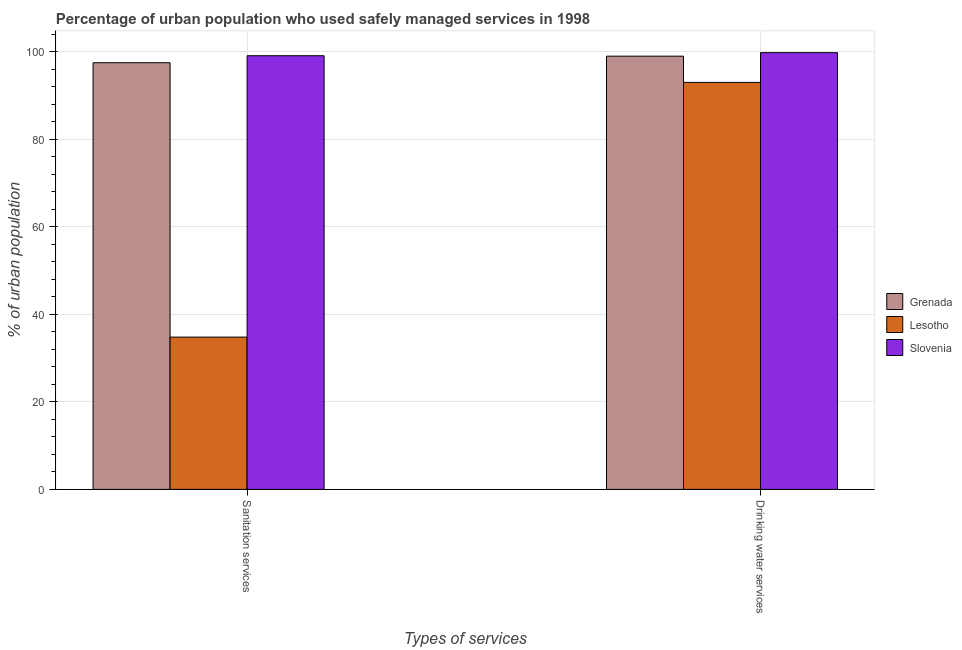How many different coloured bars are there?
Keep it short and to the point. 3. How many groups of bars are there?
Offer a very short reply. 2. What is the label of the 1st group of bars from the left?
Provide a succinct answer. Sanitation services. What is the percentage of urban population who used sanitation services in Lesotho?
Keep it short and to the point. 34.8. Across all countries, what is the maximum percentage of urban population who used sanitation services?
Your response must be concise. 99.1. Across all countries, what is the minimum percentage of urban population who used drinking water services?
Provide a succinct answer. 93. In which country was the percentage of urban population who used drinking water services maximum?
Offer a terse response. Slovenia. In which country was the percentage of urban population who used drinking water services minimum?
Your answer should be compact. Lesotho. What is the total percentage of urban population who used sanitation services in the graph?
Make the answer very short. 231.4. What is the difference between the percentage of urban population who used sanitation services in Slovenia and that in Lesotho?
Make the answer very short. 64.3. What is the difference between the percentage of urban population who used drinking water services in Grenada and the percentage of urban population who used sanitation services in Slovenia?
Your response must be concise. -0.1. What is the average percentage of urban population who used sanitation services per country?
Offer a very short reply. 77.13. What is the difference between the percentage of urban population who used drinking water services and percentage of urban population who used sanitation services in Lesotho?
Your answer should be compact. 58.2. What is the ratio of the percentage of urban population who used drinking water services in Grenada to that in Lesotho?
Your answer should be compact. 1.06. What does the 2nd bar from the left in Sanitation services represents?
Offer a terse response. Lesotho. What does the 3rd bar from the right in Sanitation services represents?
Offer a terse response. Grenada. How many bars are there?
Your answer should be very brief. 6. How many countries are there in the graph?
Your answer should be compact. 3. Are the values on the major ticks of Y-axis written in scientific E-notation?
Your answer should be compact. No. Does the graph contain any zero values?
Give a very brief answer. No. Does the graph contain grids?
Keep it short and to the point. Yes. Where does the legend appear in the graph?
Your response must be concise. Center right. How are the legend labels stacked?
Offer a terse response. Vertical. What is the title of the graph?
Make the answer very short. Percentage of urban population who used safely managed services in 1998. Does "Singapore" appear as one of the legend labels in the graph?
Provide a succinct answer. No. What is the label or title of the X-axis?
Make the answer very short. Types of services. What is the label or title of the Y-axis?
Offer a very short reply. % of urban population. What is the % of urban population of Grenada in Sanitation services?
Make the answer very short. 97.5. What is the % of urban population in Lesotho in Sanitation services?
Ensure brevity in your answer.  34.8. What is the % of urban population in Slovenia in Sanitation services?
Keep it short and to the point. 99.1. What is the % of urban population in Grenada in Drinking water services?
Provide a short and direct response. 99. What is the % of urban population in Lesotho in Drinking water services?
Provide a short and direct response. 93. What is the % of urban population in Slovenia in Drinking water services?
Your response must be concise. 99.8. Across all Types of services, what is the maximum % of urban population in Lesotho?
Provide a succinct answer. 93. Across all Types of services, what is the maximum % of urban population of Slovenia?
Keep it short and to the point. 99.8. Across all Types of services, what is the minimum % of urban population in Grenada?
Provide a short and direct response. 97.5. Across all Types of services, what is the minimum % of urban population of Lesotho?
Your answer should be very brief. 34.8. Across all Types of services, what is the minimum % of urban population of Slovenia?
Offer a very short reply. 99.1. What is the total % of urban population of Grenada in the graph?
Offer a very short reply. 196.5. What is the total % of urban population in Lesotho in the graph?
Give a very brief answer. 127.8. What is the total % of urban population in Slovenia in the graph?
Make the answer very short. 198.9. What is the difference between the % of urban population of Grenada in Sanitation services and that in Drinking water services?
Your response must be concise. -1.5. What is the difference between the % of urban population in Lesotho in Sanitation services and that in Drinking water services?
Your answer should be very brief. -58.2. What is the difference between the % of urban population of Grenada in Sanitation services and the % of urban population of Lesotho in Drinking water services?
Your answer should be compact. 4.5. What is the difference between the % of urban population in Grenada in Sanitation services and the % of urban population in Slovenia in Drinking water services?
Your answer should be very brief. -2.3. What is the difference between the % of urban population of Lesotho in Sanitation services and the % of urban population of Slovenia in Drinking water services?
Provide a short and direct response. -65. What is the average % of urban population in Grenada per Types of services?
Ensure brevity in your answer.  98.25. What is the average % of urban population of Lesotho per Types of services?
Your answer should be compact. 63.9. What is the average % of urban population in Slovenia per Types of services?
Make the answer very short. 99.45. What is the difference between the % of urban population in Grenada and % of urban population in Lesotho in Sanitation services?
Offer a very short reply. 62.7. What is the difference between the % of urban population in Grenada and % of urban population in Slovenia in Sanitation services?
Offer a very short reply. -1.6. What is the difference between the % of urban population in Lesotho and % of urban population in Slovenia in Sanitation services?
Ensure brevity in your answer.  -64.3. What is the difference between the % of urban population of Grenada and % of urban population of Lesotho in Drinking water services?
Give a very brief answer. 6. What is the difference between the % of urban population in Lesotho and % of urban population in Slovenia in Drinking water services?
Make the answer very short. -6.8. What is the ratio of the % of urban population of Lesotho in Sanitation services to that in Drinking water services?
Offer a very short reply. 0.37. What is the difference between the highest and the second highest % of urban population of Grenada?
Provide a short and direct response. 1.5. What is the difference between the highest and the second highest % of urban population in Lesotho?
Keep it short and to the point. 58.2. What is the difference between the highest and the lowest % of urban population of Lesotho?
Your answer should be compact. 58.2. 